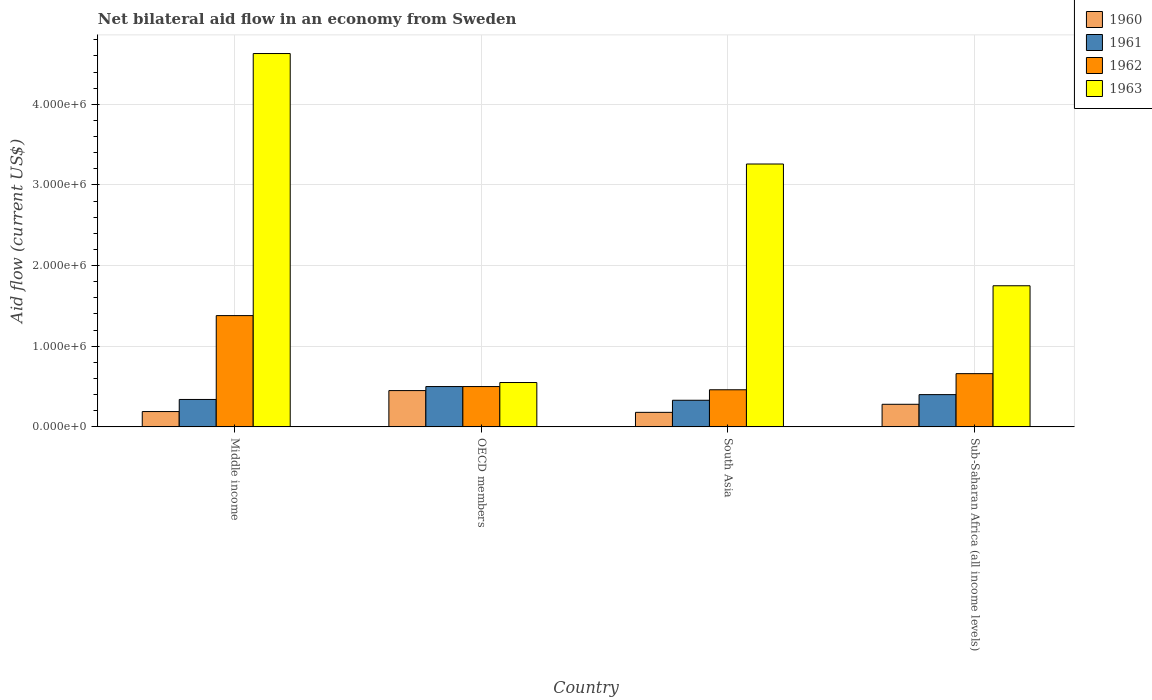Are the number of bars on each tick of the X-axis equal?
Your answer should be very brief. Yes. How many bars are there on the 1st tick from the left?
Your answer should be compact. 4. How many bars are there on the 2nd tick from the right?
Your answer should be compact. 4. What is the label of the 3rd group of bars from the left?
Your answer should be compact. South Asia. Across all countries, what is the maximum net bilateral aid flow in 1963?
Provide a short and direct response. 4.63e+06. In which country was the net bilateral aid flow in 1963 maximum?
Keep it short and to the point. Middle income. What is the total net bilateral aid flow in 1961 in the graph?
Ensure brevity in your answer.  1.57e+06. What is the difference between the net bilateral aid flow in 1963 in South Asia and the net bilateral aid flow in 1961 in Sub-Saharan Africa (all income levels)?
Give a very brief answer. 2.86e+06. What is the average net bilateral aid flow in 1961 per country?
Offer a terse response. 3.92e+05. What is the difference between the net bilateral aid flow of/in 1962 and net bilateral aid flow of/in 1963 in Sub-Saharan Africa (all income levels)?
Keep it short and to the point. -1.09e+06. Is the difference between the net bilateral aid flow in 1962 in Middle income and Sub-Saharan Africa (all income levels) greater than the difference between the net bilateral aid flow in 1963 in Middle income and Sub-Saharan Africa (all income levels)?
Offer a terse response. No. What is the difference between the highest and the second highest net bilateral aid flow in 1961?
Your response must be concise. 1.60e+05. What is the difference between the highest and the lowest net bilateral aid flow in 1963?
Provide a short and direct response. 4.08e+06. Is the sum of the net bilateral aid flow in 1960 in OECD members and Sub-Saharan Africa (all income levels) greater than the maximum net bilateral aid flow in 1962 across all countries?
Keep it short and to the point. No. Is it the case that in every country, the sum of the net bilateral aid flow in 1961 and net bilateral aid flow in 1960 is greater than the sum of net bilateral aid flow in 1962 and net bilateral aid flow in 1963?
Your response must be concise. No. Is it the case that in every country, the sum of the net bilateral aid flow in 1961 and net bilateral aid flow in 1960 is greater than the net bilateral aid flow in 1963?
Make the answer very short. No. How many bars are there?
Your answer should be very brief. 16. Are the values on the major ticks of Y-axis written in scientific E-notation?
Your response must be concise. Yes. Does the graph contain grids?
Ensure brevity in your answer.  Yes. What is the title of the graph?
Offer a very short reply. Net bilateral aid flow in an economy from Sweden. What is the label or title of the Y-axis?
Provide a succinct answer. Aid flow (current US$). What is the Aid flow (current US$) in 1960 in Middle income?
Ensure brevity in your answer.  1.90e+05. What is the Aid flow (current US$) of 1962 in Middle income?
Provide a succinct answer. 1.38e+06. What is the Aid flow (current US$) of 1963 in Middle income?
Provide a short and direct response. 4.63e+06. What is the Aid flow (current US$) of 1961 in OECD members?
Keep it short and to the point. 5.00e+05. What is the Aid flow (current US$) in 1960 in South Asia?
Provide a succinct answer. 1.80e+05. What is the Aid flow (current US$) in 1962 in South Asia?
Your answer should be very brief. 4.60e+05. What is the Aid flow (current US$) of 1963 in South Asia?
Keep it short and to the point. 3.26e+06. What is the Aid flow (current US$) of 1962 in Sub-Saharan Africa (all income levels)?
Offer a very short reply. 6.60e+05. What is the Aid flow (current US$) of 1963 in Sub-Saharan Africa (all income levels)?
Make the answer very short. 1.75e+06. Across all countries, what is the maximum Aid flow (current US$) of 1962?
Keep it short and to the point. 1.38e+06. Across all countries, what is the maximum Aid flow (current US$) of 1963?
Make the answer very short. 4.63e+06. Across all countries, what is the minimum Aid flow (current US$) in 1960?
Your answer should be compact. 1.80e+05. Across all countries, what is the minimum Aid flow (current US$) of 1961?
Make the answer very short. 3.30e+05. Across all countries, what is the minimum Aid flow (current US$) of 1963?
Offer a terse response. 5.50e+05. What is the total Aid flow (current US$) in 1960 in the graph?
Offer a very short reply. 1.10e+06. What is the total Aid flow (current US$) of 1961 in the graph?
Your answer should be compact. 1.57e+06. What is the total Aid flow (current US$) of 1963 in the graph?
Give a very brief answer. 1.02e+07. What is the difference between the Aid flow (current US$) in 1961 in Middle income and that in OECD members?
Your response must be concise. -1.60e+05. What is the difference between the Aid flow (current US$) in 1962 in Middle income and that in OECD members?
Ensure brevity in your answer.  8.80e+05. What is the difference between the Aid flow (current US$) in 1963 in Middle income and that in OECD members?
Offer a terse response. 4.08e+06. What is the difference between the Aid flow (current US$) of 1960 in Middle income and that in South Asia?
Your answer should be compact. 10000. What is the difference between the Aid flow (current US$) in 1962 in Middle income and that in South Asia?
Provide a succinct answer. 9.20e+05. What is the difference between the Aid flow (current US$) of 1963 in Middle income and that in South Asia?
Keep it short and to the point. 1.37e+06. What is the difference between the Aid flow (current US$) in 1960 in Middle income and that in Sub-Saharan Africa (all income levels)?
Your answer should be very brief. -9.00e+04. What is the difference between the Aid flow (current US$) in 1961 in Middle income and that in Sub-Saharan Africa (all income levels)?
Give a very brief answer. -6.00e+04. What is the difference between the Aid flow (current US$) in 1962 in Middle income and that in Sub-Saharan Africa (all income levels)?
Your response must be concise. 7.20e+05. What is the difference between the Aid flow (current US$) of 1963 in Middle income and that in Sub-Saharan Africa (all income levels)?
Offer a very short reply. 2.88e+06. What is the difference between the Aid flow (current US$) of 1962 in OECD members and that in South Asia?
Your answer should be very brief. 4.00e+04. What is the difference between the Aid flow (current US$) of 1963 in OECD members and that in South Asia?
Your response must be concise. -2.71e+06. What is the difference between the Aid flow (current US$) of 1962 in OECD members and that in Sub-Saharan Africa (all income levels)?
Keep it short and to the point. -1.60e+05. What is the difference between the Aid flow (current US$) of 1963 in OECD members and that in Sub-Saharan Africa (all income levels)?
Give a very brief answer. -1.20e+06. What is the difference between the Aid flow (current US$) of 1961 in South Asia and that in Sub-Saharan Africa (all income levels)?
Give a very brief answer. -7.00e+04. What is the difference between the Aid flow (current US$) in 1963 in South Asia and that in Sub-Saharan Africa (all income levels)?
Keep it short and to the point. 1.51e+06. What is the difference between the Aid flow (current US$) in 1960 in Middle income and the Aid flow (current US$) in 1961 in OECD members?
Offer a very short reply. -3.10e+05. What is the difference between the Aid flow (current US$) of 1960 in Middle income and the Aid flow (current US$) of 1962 in OECD members?
Your response must be concise. -3.10e+05. What is the difference between the Aid flow (current US$) of 1960 in Middle income and the Aid flow (current US$) of 1963 in OECD members?
Offer a very short reply. -3.60e+05. What is the difference between the Aid flow (current US$) in 1961 in Middle income and the Aid flow (current US$) in 1963 in OECD members?
Provide a short and direct response. -2.10e+05. What is the difference between the Aid flow (current US$) in 1962 in Middle income and the Aid flow (current US$) in 1963 in OECD members?
Provide a short and direct response. 8.30e+05. What is the difference between the Aid flow (current US$) in 1960 in Middle income and the Aid flow (current US$) in 1961 in South Asia?
Make the answer very short. -1.40e+05. What is the difference between the Aid flow (current US$) of 1960 in Middle income and the Aid flow (current US$) of 1963 in South Asia?
Offer a terse response. -3.07e+06. What is the difference between the Aid flow (current US$) in 1961 in Middle income and the Aid flow (current US$) in 1963 in South Asia?
Offer a very short reply. -2.92e+06. What is the difference between the Aid flow (current US$) in 1962 in Middle income and the Aid flow (current US$) in 1963 in South Asia?
Make the answer very short. -1.88e+06. What is the difference between the Aid flow (current US$) of 1960 in Middle income and the Aid flow (current US$) of 1962 in Sub-Saharan Africa (all income levels)?
Your answer should be very brief. -4.70e+05. What is the difference between the Aid flow (current US$) of 1960 in Middle income and the Aid flow (current US$) of 1963 in Sub-Saharan Africa (all income levels)?
Your answer should be very brief. -1.56e+06. What is the difference between the Aid flow (current US$) in 1961 in Middle income and the Aid flow (current US$) in 1962 in Sub-Saharan Africa (all income levels)?
Ensure brevity in your answer.  -3.20e+05. What is the difference between the Aid flow (current US$) in 1961 in Middle income and the Aid flow (current US$) in 1963 in Sub-Saharan Africa (all income levels)?
Your answer should be compact. -1.41e+06. What is the difference between the Aid flow (current US$) of 1962 in Middle income and the Aid flow (current US$) of 1963 in Sub-Saharan Africa (all income levels)?
Your answer should be compact. -3.70e+05. What is the difference between the Aid flow (current US$) of 1960 in OECD members and the Aid flow (current US$) of 1961 in South Asia?
Ensure brevity in your answer.  1.20e+05. What is the difference between the Aid flow (current US$) of 1960 in OECD members and the Aid flow (current US$) of 1962 in South Asia?
Provide a succinct answer. -10000. What is the difference between the Aid flow (current US$) of 1960 in OECD members and the Aid flow (current US$) of 1963 in South Asia?
Provide a short and direct response. -2.81e+06. What is the difference between the Aid flow (current US$) in 1961 in OECD members and the Aid flow (current US$) in 1962 in South Asia?
Provide a succinct answer. 4.00e+04. What is the difference between the Aid flow (current US$) of 1961 in OECD members and the Aid flow (current US$) of 1963 in South Asia?
Offer a terse response. -2.76e+06. What is the difference between the Aid flow (current US$) in 1962 in OECD members and the Aid flow (current US$) in 1963 in South Asia?
Keep it short and to the point. -2.76e+06. What is the difference between the Aid flow (current US$) of 1960 in OECD members and the Aid flow (current US$) of 1961 in Sub-Saharan Africa (all income levels)?
Your answer should be compact. 5.00e+04. What is the difference between the Aid flow (current US$) in 1960 in OECD members and the Aid flow (current US$) in 1963 in Sub-Saharan Africa (all income levels)?
Give a very brief answer. -1.30e+06. What is the difference between the Aid flow (current US$) of 1961 in OECD members and the Aid flow (current US$) of 1963 in Sub-Saharan Africa (all income levels)?
Make the answer very short. -1.25e+06. What is the difference between the Aid flow (current US$) in 1962 in OECD members and the Aid flow (current US$) in 1963 in Sub-Saharan Africa (all income levels)?
Give a very brief answer. -1.25e+06. What is the difference between the Aid flow (current US$) in 1960 in South Asia and the Aid flow (current US$) in 1962 in Sub-Saharan Africa (all income levels)?
Your answer should be very brief. -4.80e+05. What is the difference between the Aid flow (current US$) of 1960 in South Asia and the Aid flow (current US$) of 1963 in Sub-Saharan Africa (all income levels)?
Your answer should be very brief. -1.57e+06. What is the difference between the Aid flow (current US$) of 1961 in South Asia and the Aid flow (current US$) of 1962 in Sub-Saharan Africa (all income levels)?
Your answer should be very brief. -3.30e+05. What is the difference between the Aid flow (current US$) of 1961 in South Asia and the Aid flow (current US$) of 1963 in Sub-Saharan Africa (all income levels)?
Make the answer very short. -1.42e+06. What is the difference between the Aid flow (current US$) in 1962 in South Asia and the Aid flow (current US$) in 1963 in Sub-Saharan Africa (all income levels)?
Ensure brevity in your answer.  -1.29e+06. What is the average Aid flow (current US$) in 1960 per country?
Provide a succinct answer. 2.75e+05. What is the average Aid flow (current US$) of 1961 per country?
Offer a very short reply. 3.92e+05. What is the average Aid flow (current US$) in 1962 per country?
Keep it short and to the point. 7.50e+05. What is the average Aid flow (current US$) in 1963 per country?
Offer a terse response. 2.55e+06. What is the difference between the Aid flow (current US$) of 1960 and Aid flow (current US$) of 1961 in Middle income?
Make the answer very short. -1.50e+05. What is the difference between the Aid flow (current US$) in 1960 and Aid flow (current US$) in 1962 in Middle income?
Provide a succinct answer. -1.19e+06. What is the difference between the Aid flow (current US$) of 1960 and Aid flow (current US$) of 1963 in Middle income?
Provide a succinct answer. -4.44e+06. What is the difference between the Aid flow (current US$) in 1961 and Aid flow (current US$) in 1962 in Middle income?
Provide a short and direct response. -1.04e+06. What is the difference between the Aid flow (current US$) of 1961 and Aid flow (current US$) of 1963 in Middle income?
Make the answer very short. -4.29e+06. What is the difference between the Aid flow (current US$) of 1962 and Aid flow (current US$) of 1963 in Middle income?
Your answer should be compact. -3.25e+06. What is the difference between the Aid flow (current US$) in 1960 and Aid flow (current US$) in 1961 in OECD members?
Ensure brevity in your answer.  -5.00e+04. What is the difference between the Aid flow (current US$) in 1960 and Aid flow (current US$) in 1962 in OECD members?
Give a very brief answer. -5.00e+04. What is the difference between the Aid flow (current US$) of 1960 and Aid flow (current US$) of 1963 in OECD members?
Ensure brevity in your answer.  -1.00e+05. What is the difference between the Aid flow (current US$) of 1961 and Aid flow (current US$) of 1963 in OECD members?
Your response must be concise. -5.00e+04. What is the difference between the Aid flow (current US$) in 1960 and Aid flow (current US$) in 1961 in South Asia?
Keep it short and to the point. -1.50e+05. What is the difference between the Aid flow (current US$) of 1960 and Aid flow (current US$) of 1962 in South Asia?
Keep it short and to the point. -2.80e+05. What is the difference between the Aid flow (current US$) in 1960 and Aid flow (current US$) in 1963 in South Asia?
Provide a short and direct response. -3.08e+06. What is the difference between the Aid flow (current US$) of 1961 and Aid flow (current US$) of 1962 in South Asia?
Your response must be concise. -1.30e+05. What is the difference between the Aid flow (current US$) in 1961 and Aid flow (current US$) in 1963 in South Asia?
Offer a terse response. -2.93e+06. What is the difference between the Aid flow (current US$) in 1962 and Aid flow (current US$) in 1963 in South Asia?
Your answer should be compact. -2.80e+06. What is the difference between the Aid flow (current US$) in 1960 and Aid flow (current US$) in 1961 in Sub-Saharan Africa (all income levels)?
Provide a short and direct response. -1.20e+05. What is the difference between the Aid flow (current US$) in 1960 and Aid flow (current US$) in 1962 in Sub-Saharan Africa (all income levels)?
Your response must be concise. -3.80e+05. What is the difference between the Aid flow (current US$) of 1960 and Aid flow (current US$) of 1963 in Sub-Saharan Africa (all income levels)?
Keep it short and to the point. -1.47e+06. What is the difference between the Aid flow (current US$) of 1961 and Aid flow (current US$) of 1962 in Sub-Saharan Africa (all income levels)?
Your response must be concise. -2.60e+05. What is the difference between the Aid flow (current US$) of 1961 and Aid flow (current US$) of 1963 in Sub-Saharan Africa (all income levels)?
Offer a terse response. -1.35e+06. What is the difference between the Aid flow (current US$) of 1962 and Aid flow (current US$) of 1963 in Sub-Saharan Africa (all income levels)?
Give a very brief answer. -1.09e+06. What is the ratio of the Aid flow (current US$) of 1960 in Middle income to that in OECD members?
Your answer should be very brief. 0.42. What is the ratio of the Aid flow (current US$) in 1961 in Middle income to that in OECD members?
Keep it short and to the point. 0.68. What is the ratio of the Aid flow (current US$) of 1962 in Middle income to that in OECD members?
Give a very brief answer. 2.76. What is the ratio of the Aid flow (current US$) of 1963 in Middle income to that in OECD members?
Give a very brief answer. 8.42. What is the ratio of the Aid flow (current US$) in 1960 in Middle income to that in South Asia?
Provide a short and direct response. 1.06. What is the ratio of the Aid flow (current US$) of 1961 in Middle income to that in South Asia?
Your response must be concise. 1.03. What is the ratio of the Aid flow (current US$) in 1962 in Middle income to that in South Asia?
Make the answer very short. 3. What is the ratio of the Aid flow (current US$) in 1963 in Middle income to that in South Asia?
Provide a short and direct response. 1.42. What is the ratio of the Aid flow (current US$) in 1960 in Middle income to that in Sub-Saharan Africa (all income levels)?
Offer a very short reply. 0.68. What is the ratio of the Aid flow (current US$) of 1962 in Middle income to that in Sub-Saharan Africa (all income levels)?
Offer a terse response. 2.09. What is the ratio of the Aid flow (current US$) in 1963 in Middle income to that in Sub-Saharan Africa (all income levels)?
Give a very brief answer. 2.65. What is the ratio of the Aid flow (current US$) in 1961 in OECD members to that in South Asia?
Your response must be concise. 1.52. What is the ratio of the Aid flow (current US$) in 1962 in OECD members to that in South Asia?
Your answer should be very brief. 1.09. What is the ratio of the Aid flow (current US$) in 1963 in OECD members to that in South Asia?
Offer a terse response. 0.17. What is the ratio of the Aid flow (current US$) in 1960 in OECD members to that in Sub-Saharan Africa (all income levels)?
Your answer should be compact. 1.61. What is the ratio of the Aid flow (current US$) in 1962 in OECD members to that in Sub-Saharan Africa (all income levels)?
Provide a succinct answer. 0.76. What is the ratio of the Aid flow (current US$) in 1963 in OECD members to that in Sub-Saharan Africa (all income levels)?
Give a very brief answer. 0.31. What is the ratio of the Aid flow (current US$) of 1960 in South Asia to that in Sub-Saharan Africa (all income levels)?
Keep it short and to the point. 0.64. What is the ratio of the Aid flow (current US$) of 1961 in South Asia to that in Sub-Saharan Africa (all income levels)?
Ensure brevity in your answer.  0.82. What is the ratio of the Aid flow (current US$) of 1962 in South Asia to that in Sub-Saharan Africa (all income levels)?
Provide a succinct answer. 0.7. What is the ratio of the Aid flow (current US$) of 1963 in South Asia to that in Sub-Saharan Africa (all income levels)?
Keep it short and to the point. 1.86. What is the difference between the highest and the second highest Aid flow (current US$) in 1961?
Keep it short and to the point. 1.00e+05. What is the difference between the highest and the second highest Aid flow (current US$) of 1962?
Provide a short and direct response. 7.20e+05. What is the difference between the highest and the second highest Aid flow (current US$) of 1963?
Offer a very short reply. 1.37e+06. What is the difference between the highest and the lowest Aid flow (current US$) in 1961?
Offer a very short reply. 1.70e+05. What is the difference between the highest and the lowest Aid flow (current US$) in 1962?
Provide a short and direct response. 9.20e+05. What is the difference between the highest and the lowest Aid flow (current US$) in 1963?
Your answer should be compact. 4.08e+06. 